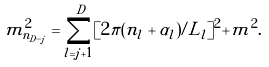<formula> <loc_0><loc_0><loc_500><loc_500>m _ { n _ { D - j } } ^ { 2 } = \sum _ { l = j + 1 } ^ { D } [ 2 \pi ( n _ { l } + \alpha _ { l } ) / L _ { l } ] ^ { 2 } + m ^ { 2 } .</formula> 